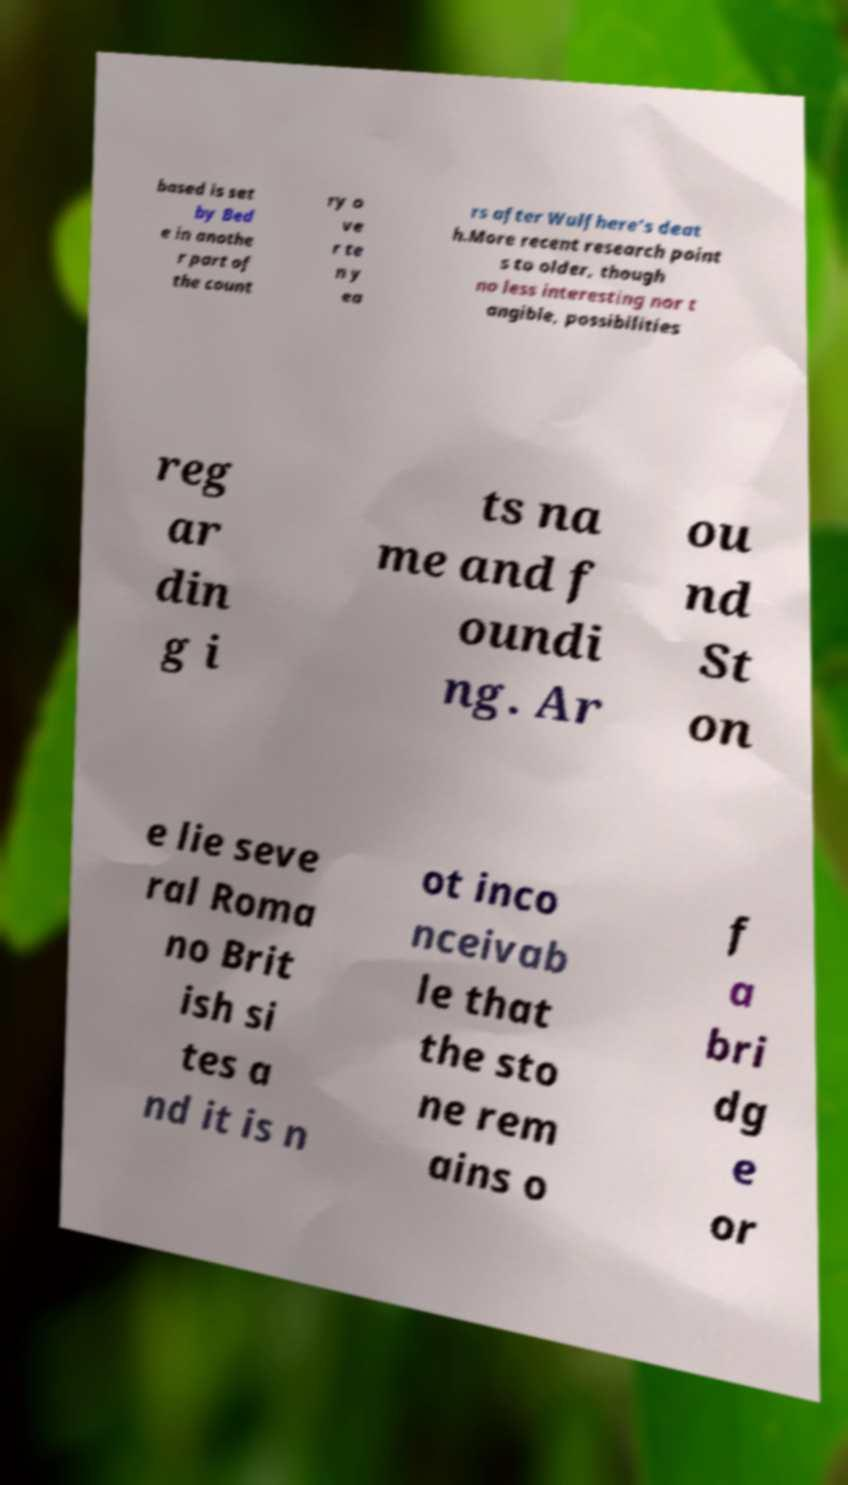Please identify and transcribe the text found in this image. based is set by Bed e in anothe r part of the count ry o ve r te n y ea rs after Wulfhere's deat h.More recent research point s to older, though no less interesting nor t angible, possibilities reg ar din g i ts na me and f oundi ng. Ar ou nd St on e lie seve ral Roma no Brit ish si tes a nd it is n ot inco nceivab le that the sto ne rem ains o f a bri dg e or 